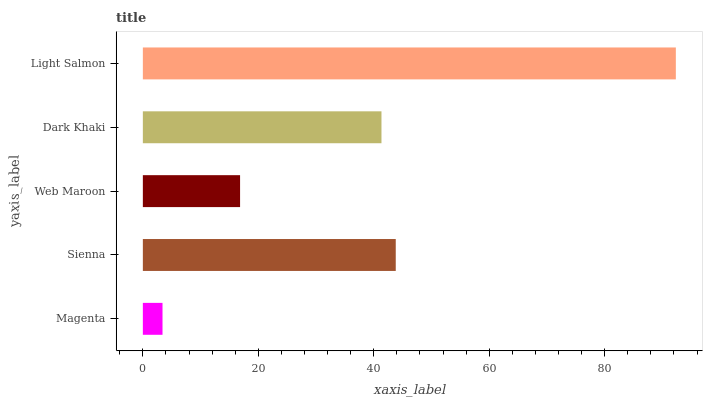Is Magenta the minimum?
Answer yes or no. Yes. Is Light Salmon the maximum?
Answer yes or no. Yes. Is Sienna the minimum?
Answer yes or no. No. Is Sienna the maximum?
Answer yes or no. No. Is Sienna greater than Magenta?
Answer yes or no. Yes. Is Magenta less than Sienna?
Answer yes or no. Yes. Is Magenta greater than Sienna?
Answer yes or no. No. Is Sienna less than Magenta?
Answer yes or no. No. Is Dark Khaki the high median?
Answer yes or no. Yes. Is Dark Khaki the low median?
Answer yes or no. Yes. Is Web Maroon the high median?
Answer yes or no. No. Is Sienna the low median?
Answer yes or no. No. 